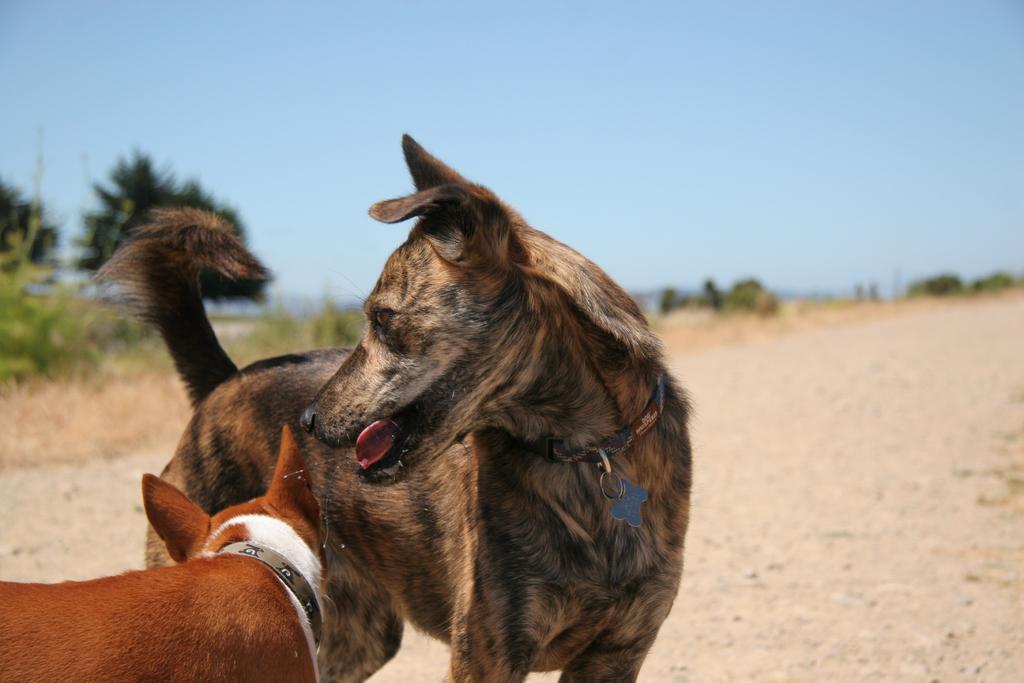Please provide a concise description of this image. In this image, I can see two dogs standing. I think these are the dog belts. In the background, I can see the trees and plants. This is the sky. 